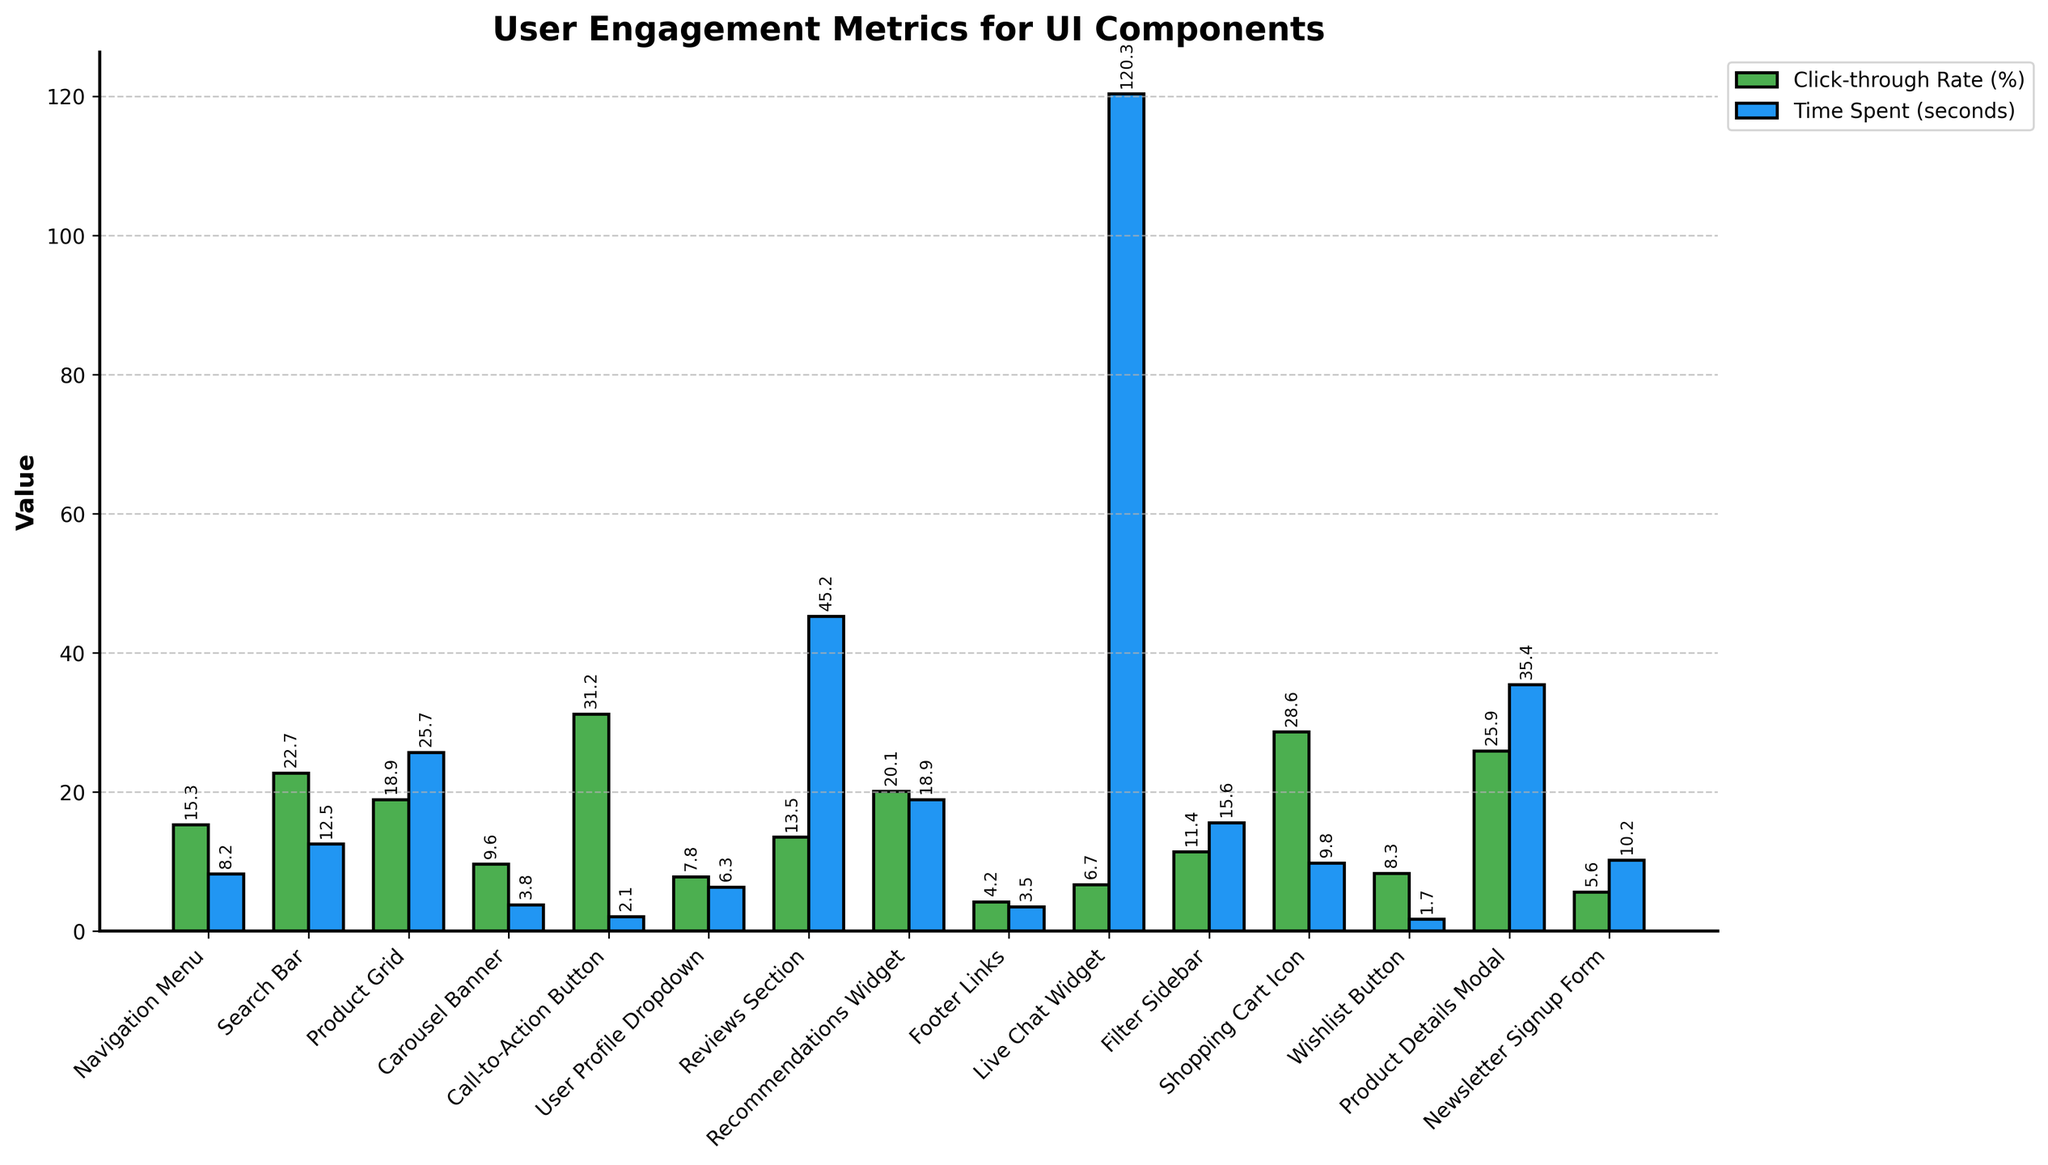Which component has the highest click-through rate? The component with the highest click-through rate will have the tallest green bar on the left side. This is the Call-to-Action Button with a click-through rate of 31.2%.
Answer: Call-to-Action Button Which component has the lowest time spent? The component with the lowest time spent will have the shortest blue bar on the right side. This is the Wishlist Button with a time spent of 1.7 seconds.
Answer: Wishlist Button What is the total click-through rate for the Navigation Menu and Product Grid combined? Add the click-through rates for the Navigation Menu (15.3%) and Product Grid (18.9%). 15.3 + 18.9 = 34.2.
Answer: 34.2% How does the time spent on the Reviews Section compare to the Product Details Modal? Compare the height of the blue bars for the Reviews Section and Product Details Modal. Reviews Section has 45.2 seconds and Product Details Modal has 35.4 seconds. The Reviews Section is higher.
Answer: More on Reviews Section Which UI component has a higher click-through rate, the Wishlist Button or the Navigation Menu? Compare the height of the green bars for both components. The Wishlist Button (8.3%) is lower than the Navigation Menu (15.3%).
Answer: Navigation Menu What is the difference in time spent between the Live Chat Widget and the Footer Links? Subtract the time spent on Footer Links (3.5 seconds) from the time spent on the Live Chat Widget (120.3 seconds). 120.3 - 3.5 = 116.8.
Answer: 116.8 seconds Which UI component has closer values between click-through rate and time spent? Compare the green and blue bars for each component to see which ones have the closest height. The Search Bar has values closest together (22.7% and 12.5 seconds).
Answer: Search Bar What is the average time spent across all components? Add the time spent for all components and divide by the number of components (15). (8.2 + 12.5 + 25.7 + 3.8 + 2.1 + 6.3 + 45.2 + 18.9 + 3.5 + 120.3 + 15.6 + 9.8 + 1.7 + 35.4 + 10.2) / 15 = 19.2 seconds.
Answer: 19.2 seconds 